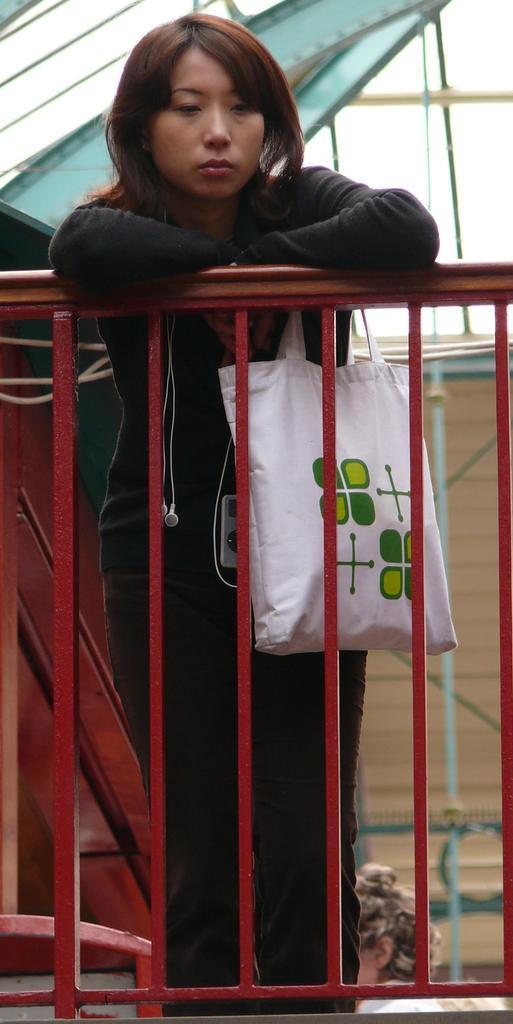Can you describe this image briefly? This is the woman standing and holding white color bag. This is the grill which is red in color. 